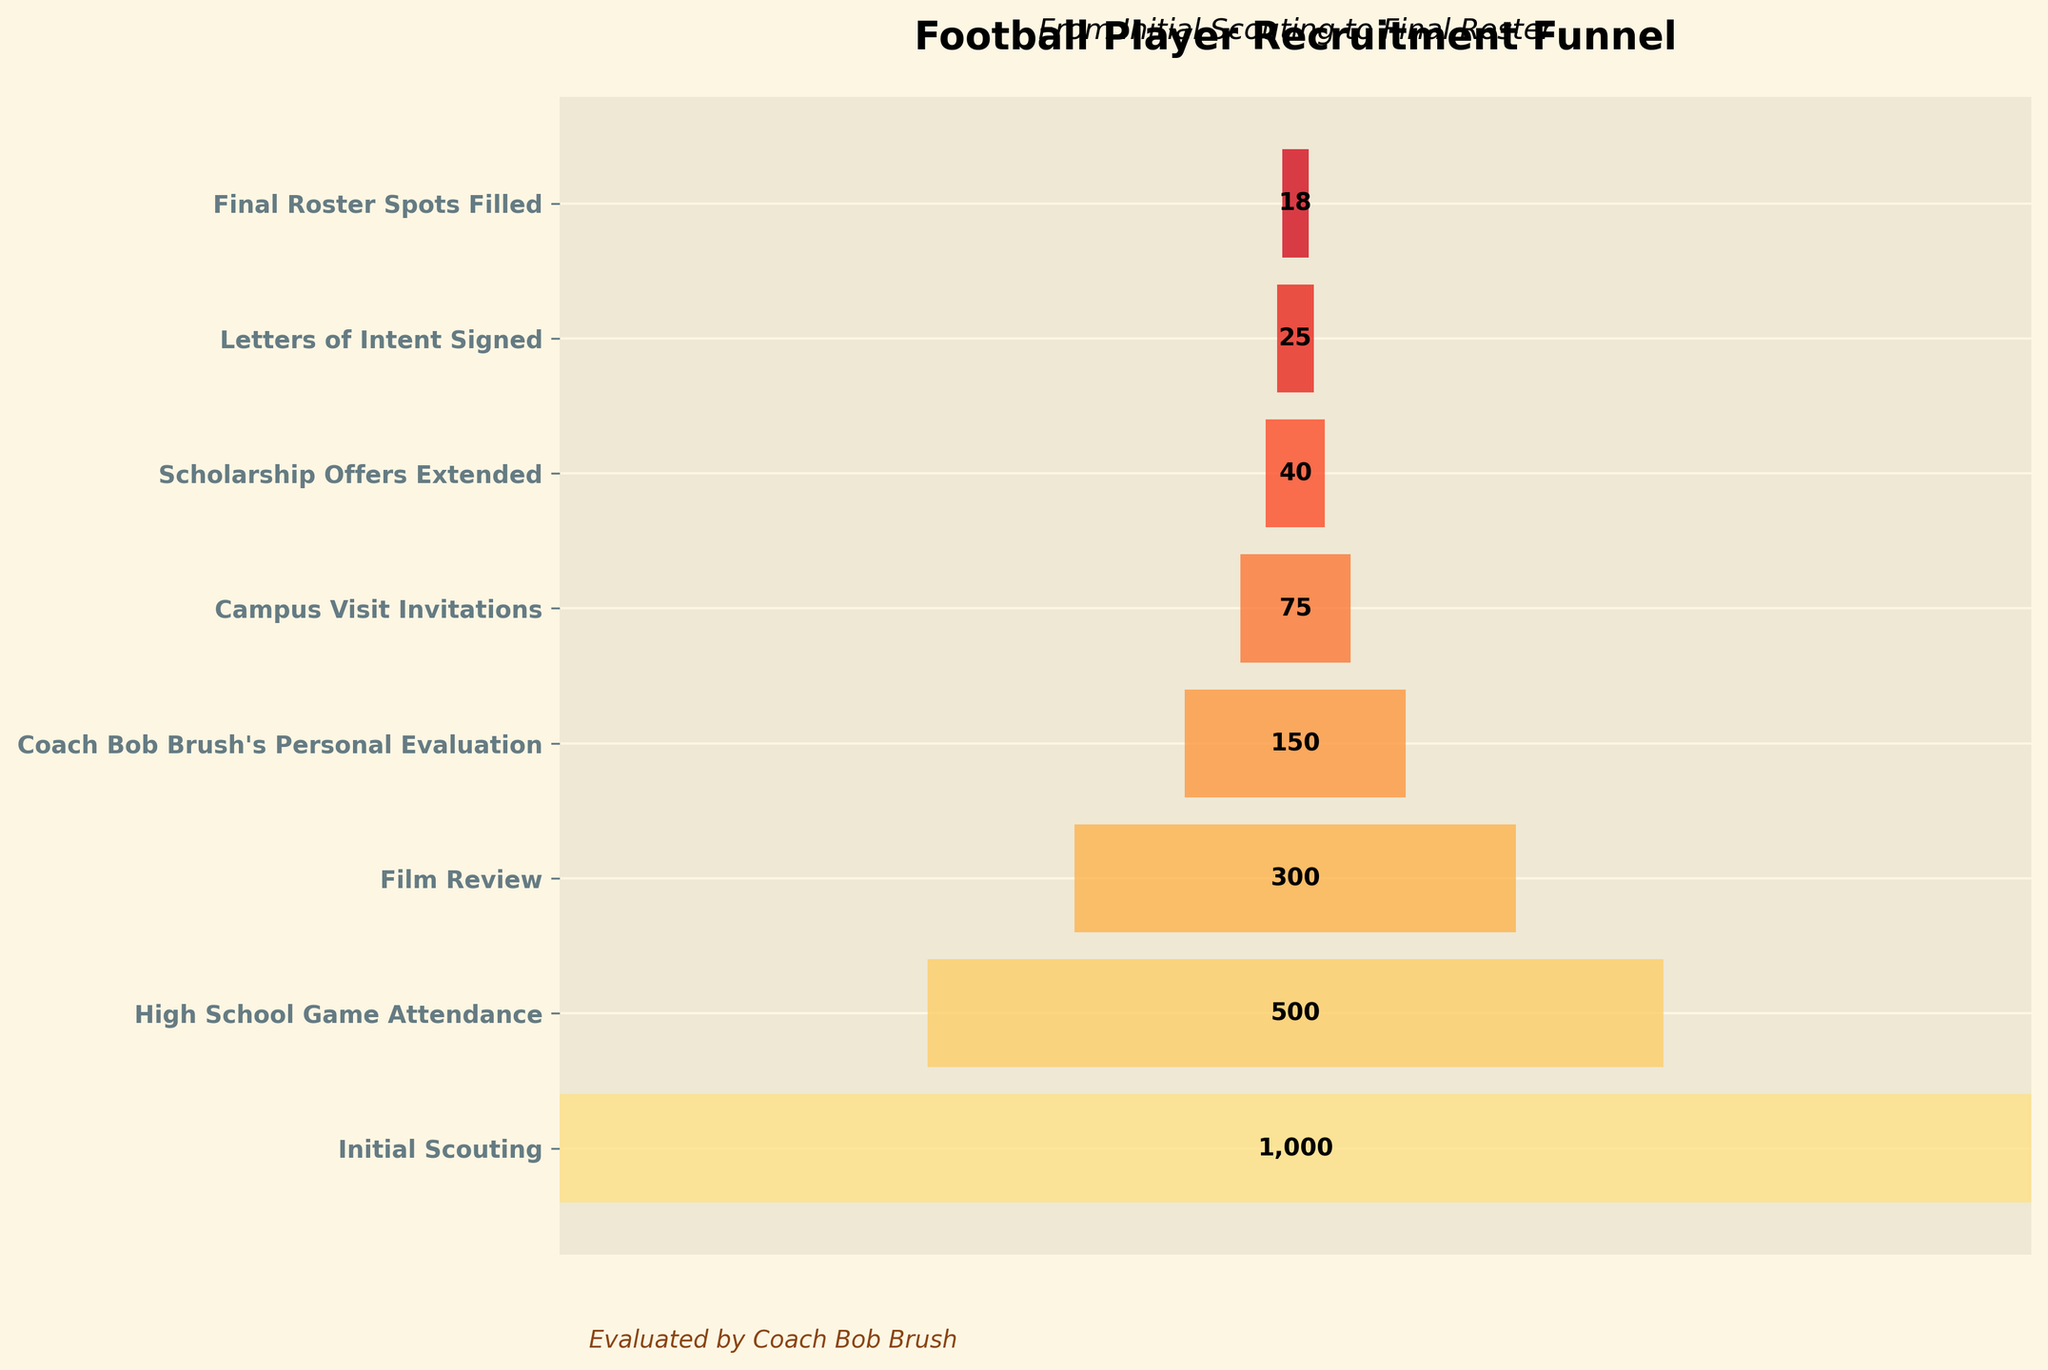How many stages are included in the player recruitment funnel? The figure has a vertical axis with labeled stages representing each step in the recruitment process. Counting these labels shows there are eight stages.
Answer: 8 What is the initial number of players scouted? The first stage of the funnel, labeled "Initial Scouting," has a bar with the number of players annotated. This number is 1,000.
Answer: 1,000 What is the title of the funnel chart? The top part of the figure contains the title, which reads "Football Player Recruitment Funnel."
Answer: Football Player Recruitment Funnel Which stage has the largest reduction in player numbers? Comparing the number of players between consecutive stages, the largest drop is between "Initial Scouting" (1000 players) and "High School Game Attendance" (500 players), a difference of 500.
Answer: Initial Scouting to High School Game Attendance How many players received scholarship offers? The stage labeled "Scholarship Offers Extended" shows the number of players is 40, as indicated by the bar annotation.
Answer: 40 What is the difference in player count between the Film Review and Coach Bob Brush's Personal Evaluation stages? The number of players in the Film Review stage is 300, and in Coach Bob Brush's Personal Evaluation stage is 150. The difference is 300 - 150 = 150.
Answer: 150 How many players were invited to campus visits? The bar associated with the "Campus Visit Invitations" stage is annotated with 75 players, indicating the number invited for campus visits.
Answer: 75 How many players ended up on the final roster? The final stage "Final Roster Spots Filled" shows 18 players, as indicated by the bar annotation.
Answer: 18 By what percentage does the player count decrease from Coach Bob Brush's Personal Evaluation stage to Campus Visit Invitations stage? The number of players decreases from 150 in Coach Bob Brush's stage to 75 in Campus Visit Invitations. Percentage decrease is calculated as ((150-75)/150) * 100 = 50%.
Answer: 50% What proportion of initially scouted players ended up filling final roster spots? Initially, 1000 players are scouted, and 18 fill the final roster spots. The proportion is 18/1000, which simplifies to 0.018 or 1.8%.
Answer: 1.8% 